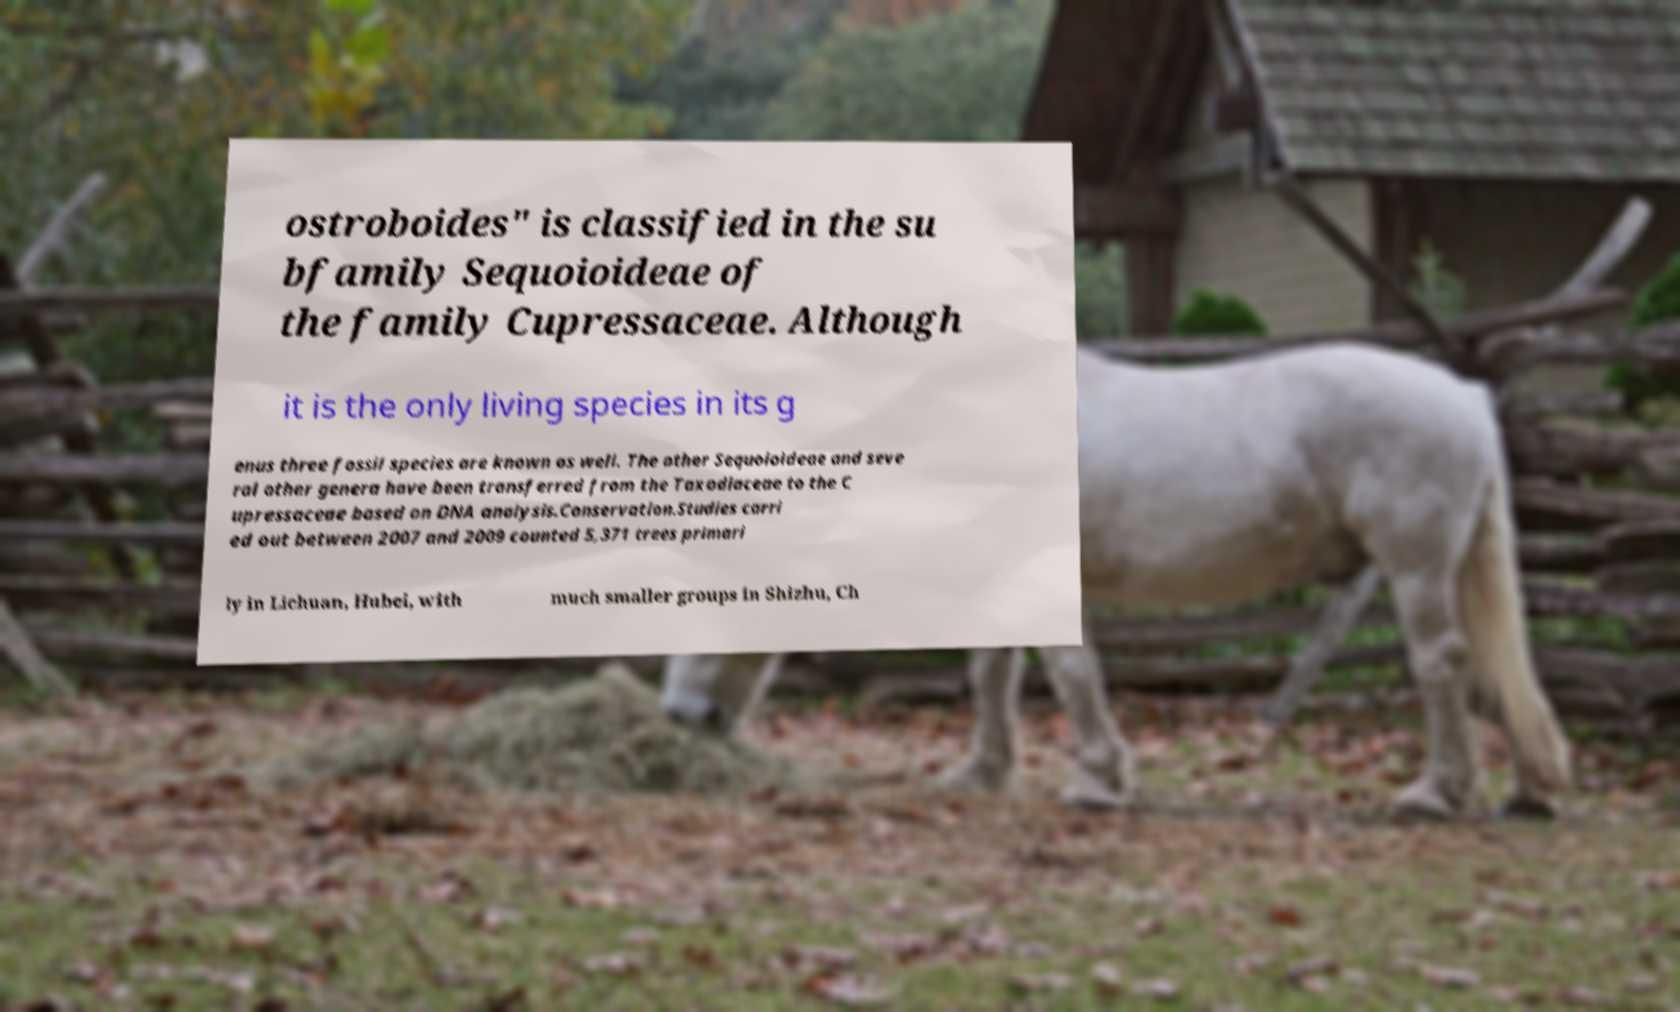I need the written content from this picture converted into text. Can you do that? ostroboides" is classified in the su bfamily Sequoioideae of the family Cupressaceae. Although it is the only living species in its g enus three fossil species are known as well. The other Sequoioideae and seve ral other genera have been transferred from the Taxodiaceae to the C upressaceae based on DNA analysis.Conservation.Studies carri ed out between 2007 and 2009 counted 5,371 trees primari ly in Lichuan, Hubei, with much smaller groups in Shizhu, Ch 